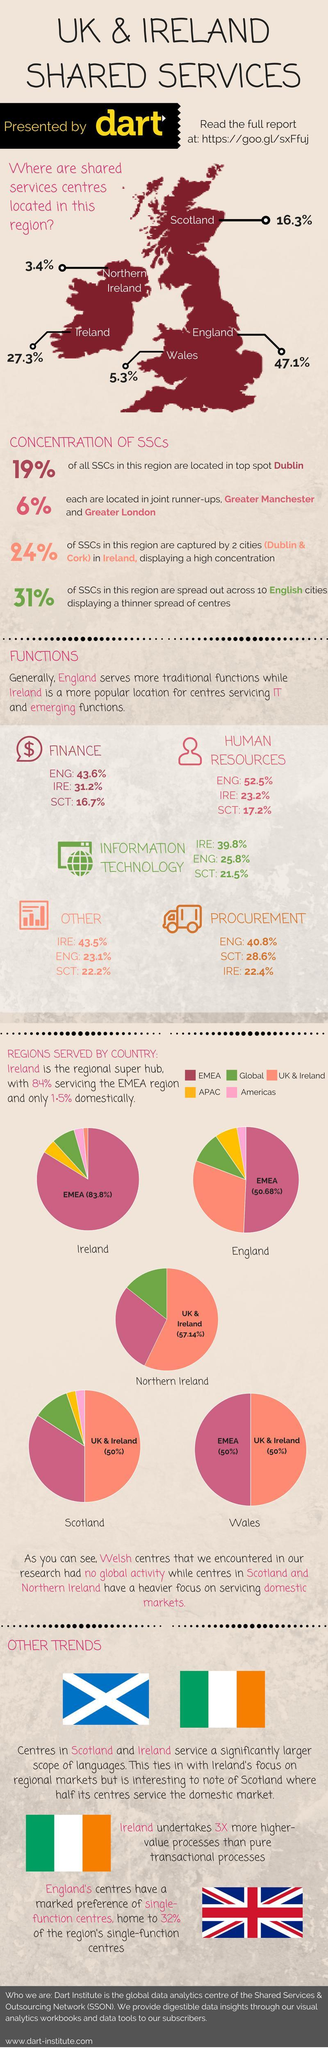How many pie charts are shown here?
Answer the question with a short phrase. 5 How many service sectors are mentioned? 5 Which are the three regions to which Scotland provides less than 25% of its services? Americas, APAC, global In which region, does Scotland have less than 50% but more than 25% of the service centres? EMEA What percentage of shared services are located in Ireland and Northern Ireland? 30.7% Who provides more services in human resources? England In which region does Ireland have least of its service centres? UK & Ireland In which region does Northern Ireland have majority of service centres? UK & Ireland What is the percentage of services provided by England to EMEA? 50.68% What is the percentage of services provided by Scotland in Procurement? 28.6% What percentage of shared service centres are located in Ireland? 27.3% How many countries are named on the map? 5 With regards to 'concentration of SSCs', which are the top three 'cities'? Dublin, Greater Manchester, Greater London In Which two regions does Wales have all its service centres? EMEA, UK & Ireland In which of the regions does Northern Ireland 'not have' its service centres? Americas, APAC In which region does Ireland have majority of its service centres? EMEA What percentage of shared service centres are located in Scotland? 16.3% What is the percentage of services provided by Northern Ireland to the global and EMEA regions? 42.86 In which country are majority of the shared service centres located? England In which region does England have majority of its service centres? EMEA Which country accepts transactional processes thrice its number of value processes? Ireland 